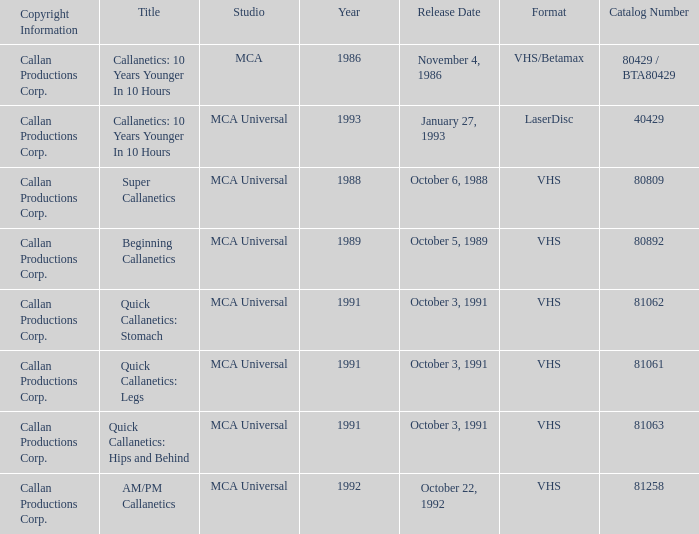Name the format for super callanetics VHS. 